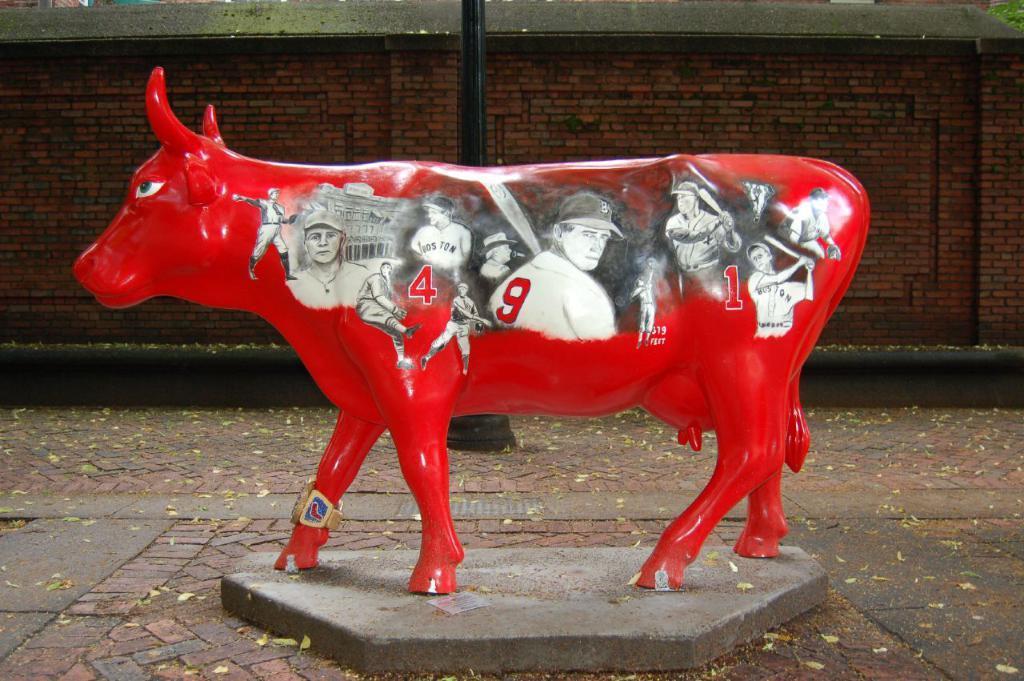How would you summarize this image in a sentence or two? In this image we can see a statue with some pictures of people and numbers on it. On the backside we can see a pole and a wall. 